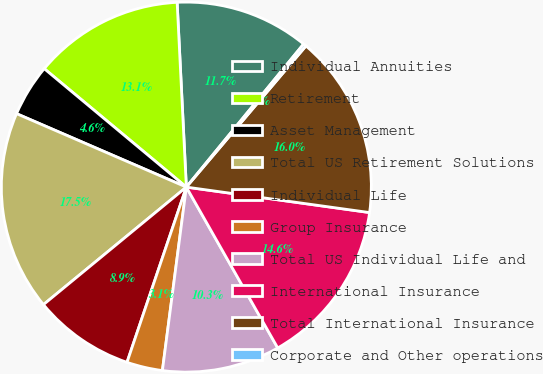Convert chart. <chart><loc_0><loc_0><loc_500><loc_500><pie_chart><fcel>Individual Annuities<fcel>Retirement<fcel>Asset Management<fcel>Total US Retirement Solutions<fcel>Individual Life<fcel>Group Insurance<fcel>Total US Individual Life and<fcel>International Insurance<fcel>Total International Insurance<fcel>Corporate and Other operations<nl><fcel>11.72%<fcel>13.15%<fcel>4.56%<fcel>17.45%<fcel>8.85%<fcel>3.13%<fcel>10.29%<fcel>14.58%<fcel>16.01%<fcel>0.26%<nl></chart> 